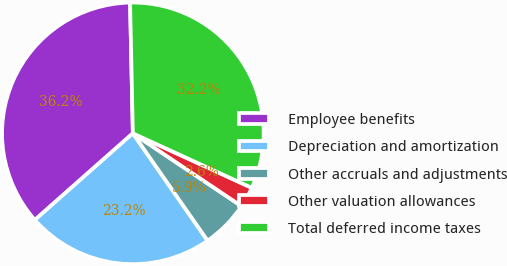<chart> <loc_0><loc_0><loc_500><loc_500><pie_chart><fcel>Employee benefits<fcel>Depreciation and amortization<fcel>Other accruals and adjustments<fcel>Other valuation allowances<fcel>Total deferred income taxes<nl><fcel>36.18%<fcel>23.16%<fcel>5.92%<fcel>2.56%<fcel>32.18%<nl></chart> 